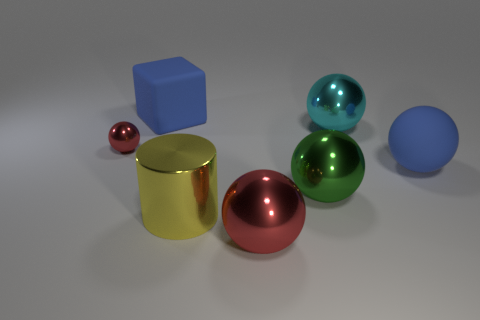Subtract all big rubber spheres. How many spheres are left? 4 Subtract all blue spheres. How many spheres are left? 4 Subtract all purple balls. Subtract all cyan cylinders. How many balls are left? 5 Add 2 green things. How many objects exist? 9 Subtract all cylinders. How many objects are left? 6 Subtract 0 cyan blocks. How many objects are left? 7 Subtract all big yellow objects. Subtract all blue blocks. How many objects are left? 5 Add 3 tiny things. How many tiny things are left? 4 Add 4 red shiny balls. How many red shiny balls exist? 6 